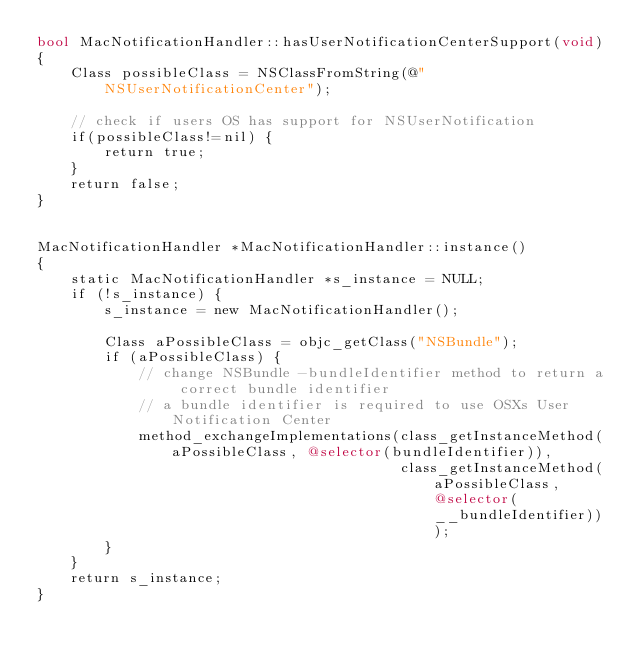<code> <loc_0><loc_0><loc_500><loc_500><_ObjectiveC_>bool MacNotificationHandler::hasUserNotificationCenterSupport(void)
{
    Class possibleClass = NSClassFromString(@"NSUserNotificationCenter");

    // check if users OS has support for NSUserNotification
    if(possibleClass!=nil) {
        return true;
    }
    return false;
}


MacNotificationHandler *MacNotificationHandler::instance()
{
    static MacNotificationHandler *s_instance = NULL;
    if (!s_instance) {
        s_instance = new MacNotificationHandler();
        
        Class aPossibleClass = objc_getClass("NSBundle");
        if (aPossibleClass) {
            // change NSBundle -bundleIdentifier method to return a correct bundle identifier
            // a bundle identifier is required to use OSXs User Notification Center
            method_exchangeImplementations(class_getInstanceMethod(aPossibleClass, @selector(bundleIdentifier)),
                                           class_getInstanceMethod(aPossibleClass, @selector(__bundleIdentifier)));
        }
    }
    return s_instance;
}
</code> 